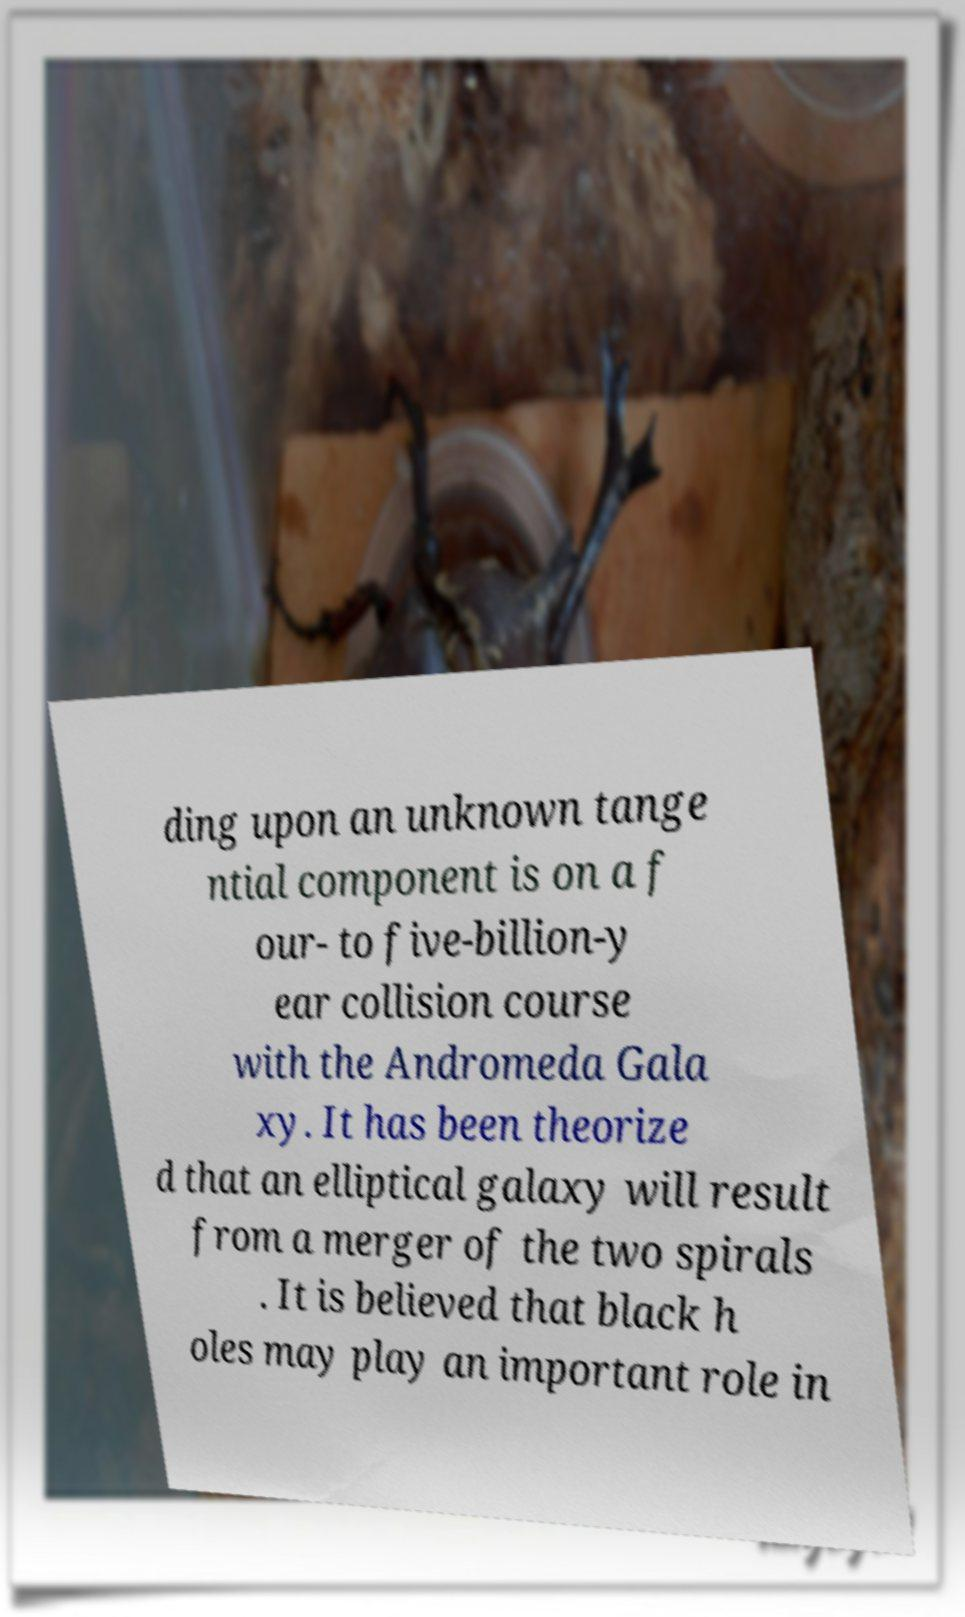Please identify and transcribe the text found in this image. ding upon an unknown tange ntial component is on a f our- to five-billion-y ear collision course with the Andromeda Gala xy. It has been theorize d that an elliptical galaxy will result from a merger of the two spirals . It is believed that black h oles may play an important role in 